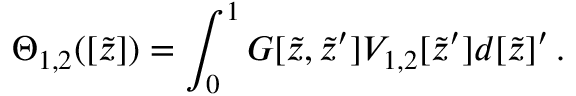Convert formula to latex. <formula><loc_0><loc_0><loc_500><loc_500>\Theta _ { 1 , 2 } ( [ \widetilde { z } ] ) = \int _ { 0 } ^ { 1 } G [ \widetilde { z } , \widetilde { z } ^ { \prime } ] V _ { 1 , 2 } [ \widetilde { z } ^ { \prime } ] d { [ \widetilde { z } ] ^ { \prime } } \, . \</formula> 